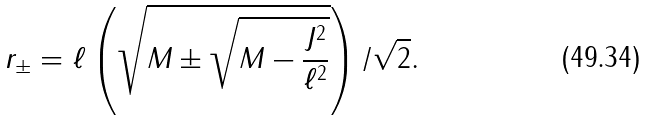<formula> <loc_0><loc_0><loc_500><loc_500>r _ { \pm } = \ell \left ( \sqrt { M \pm \sqrt { M - \frac { J ^ { 2 } } { \ell ^ { 2 } } } } \right ) / \sqrt { 2 } .</formula> 